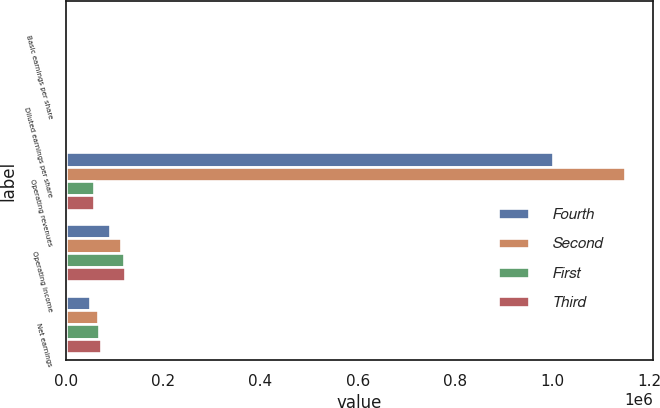Convert chart. <chart><loc_0><loc_0><loc_500><loc_500><stacked_bar_chart><ecel><fcel>Basic earnings per share<fcel>Diluted earnings per share<fcel>Operating revenues<fcel>Operating income<fcel>Net earnings<nl><fcel>Fourth<fcel>0.58<fcel>0.57<fcel>1.00078e+06<fcel>89823<fcel>50095<nl><fcel>Second<fcel>0.69<fcel>0.67<fcel>1.14986e+06<fcel>113443<fcel>65696<nl><fcel>First<fcel>0.66<fcel>0.65<fcel>57895.5<fcel>118680<fcel>68650<nl><fcel>Third<fcel>0.71<fcel>0.7<fcel>57895.5<fcel>122287<fcel>72565<nl></chart> 